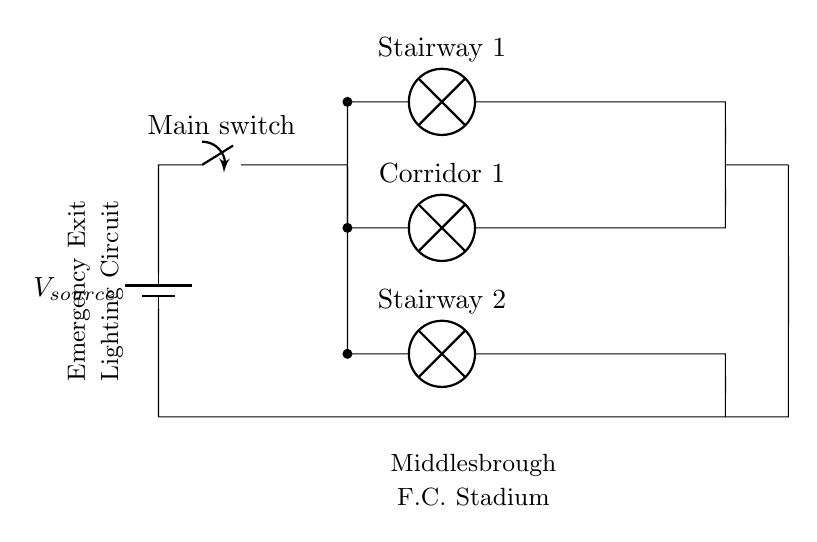What types of lighting are used in this circuit? The circuit diagram shows three lamps, specifically labeled as Stairway 1, Corridor 1, and Stairway 2, indicating they are designed for emergency exit lighting.
Answer: Stairway 1, Corridor 1, Stairway 2 How many lamps are connected in parallel? There are three lamps (Stairway 1, Corridor 1, and Stairway 2) shown in the circuit diagram, all connected in parallel to the same voltage source, which allows them to operate independently.
Answer: Three What happens if one lamp fails? Since the lamps are in a parallel configuration, if one lamp fails, the others will continue to operate because they each have their own path to the power source.
Answer: Others continue to operate What is the purpose of the main switch? The main switch serves to turn the entire emergency lighting circuit on or off, controlling the flow of electricity to all connected lamps simultaneously.
Answer: To control the circuit What is the nature of the circuit configuration? The circuit is configured as parallel, meaning that all lamps are connected across the same voltage source and can function independently, maintaining the circuit's overall operation if one component fails.
Answer: Parallel What does the battery represent in this circuit? The battery in the circuit diagram represents the power source providing the necessary voltage for the emergency exit lights to function, even in the event of a power failure.
Answer: Power source 